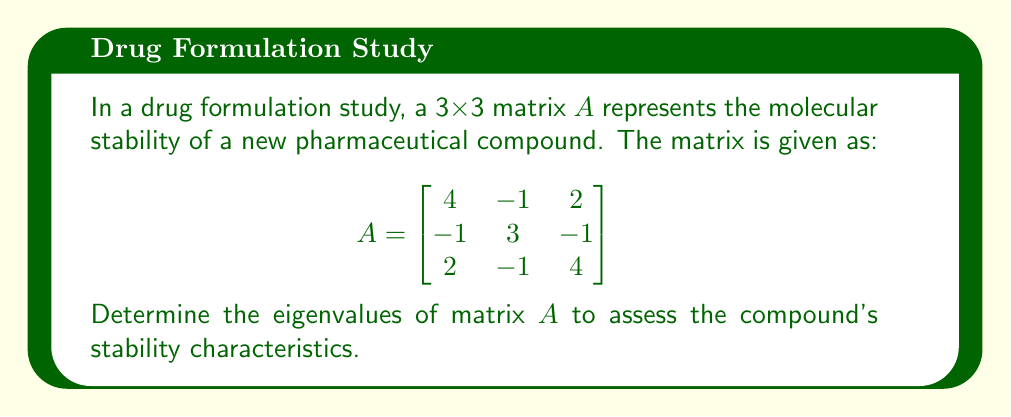Give your solution to this math problem. To find the eigenvalues of matrix $A$, we need to solve the characteristic equation:

1) First, we set up the equation $\det(A - \lambda I) = 0$, where $I$ is the 3x3 identity matrix:

   $$\det \begin{bmatrix}
   4-\lambda & -1 & 2 \\
   -1 & 3-\lambda & -1 \\
   2 & -1 & 4-\lambda
   \end{bmatrix} = 0$$

2) Expand the determinant:
   $$(4-\lambda)[(3-\lambda)(4-\lambda) - 1] + (-1)[(-1)(4-\lambda) - 2(-1)] + 2[(-1)(-1) - (3-\lambda)(2)] = 0$$

3) Simplify:
   $$(4-\lambda)[(12-7\lambda+\lambda^2) - 1] + (-1)[-4+\lambda+2] + 2[1 - 6+2\lambda] = 0$$
   $$(4-\lambda)(11-7\lambda+\lambda^2) + (-1)[-2+\lambda] + 2[-5+2\lambda] = 0$$

4) Expand further:
   $$44-28\lambda+4\lambda^2-11\lambda+7\lambda^2-\lambda^3 + 2-\lambda - 10+4\lambda = 0$$

5) Collect like terms:
   $$-\lambda^3 + 11\lambda^2 - 25\lambda + 36 = 0$$

6) This is the characteristic polynomial. To solve it, we can factor out $(\lambda - 2)$:
   $$(\lambda - 2)(-\lambda^2 + 9\lambda - 18) = 0$$

7) Further factoring gives:
   $$(\lambda - 2)(\lambda - 3)(\lambda - 6) = 0$$

8) The solutions to this equation are the eigenvalues.
Answer: $\lambda_1 = 2$, $\lambda_2 = 3$, $\lambda_3 = 6$ 